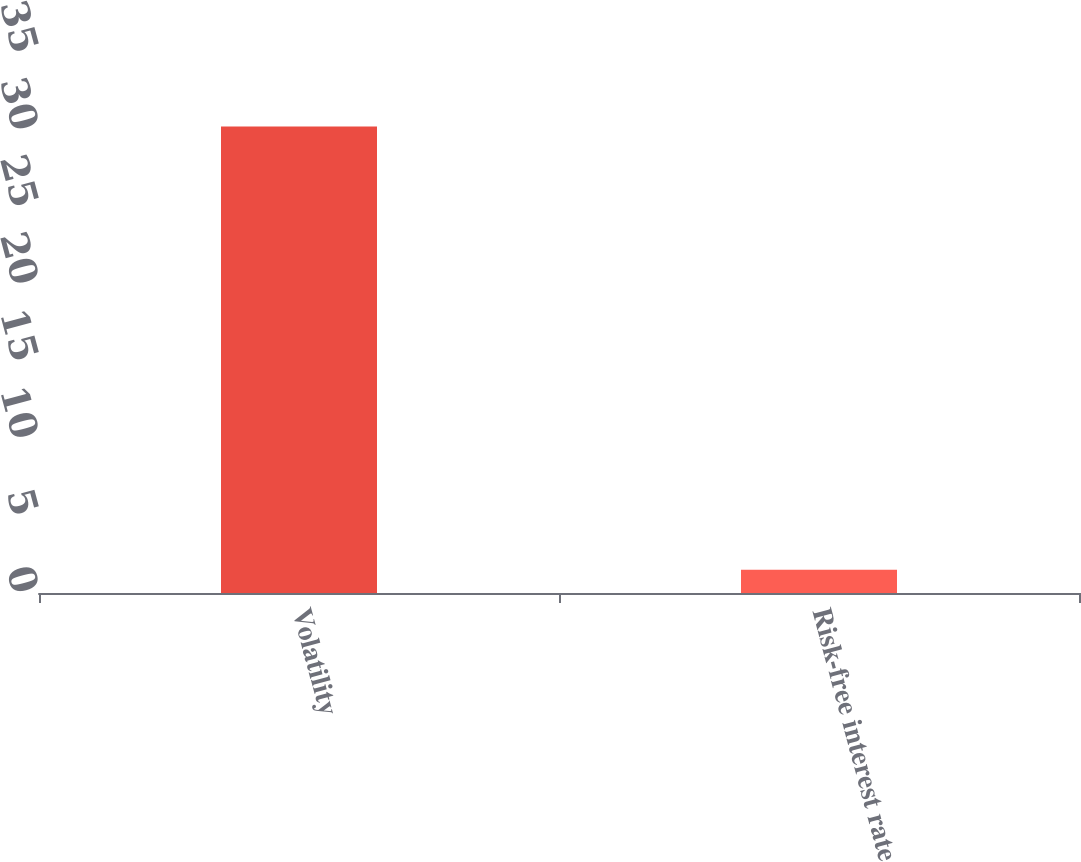<chart> <loc_0><loc_0><loc_500><loc_500><bar_chart><fcel>Volatility<fcel>Risk-free interest rate<nl><fcel>30.24<fcel>1.5<nl></chart> 